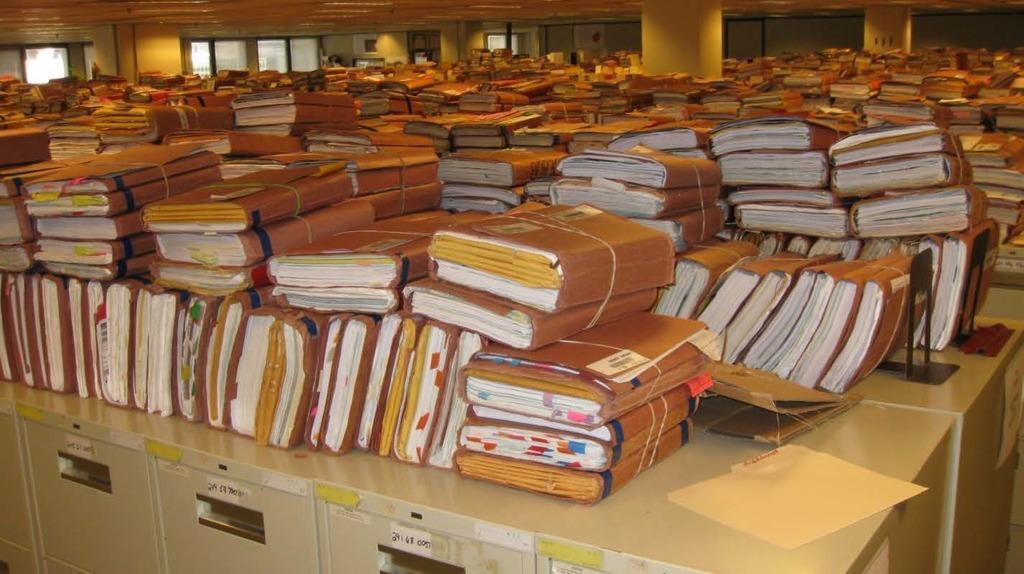Please provide a concise description of this image. In this image we can see there are so many files are arranged on the tables. In the background there are pillars, wall and windows. 